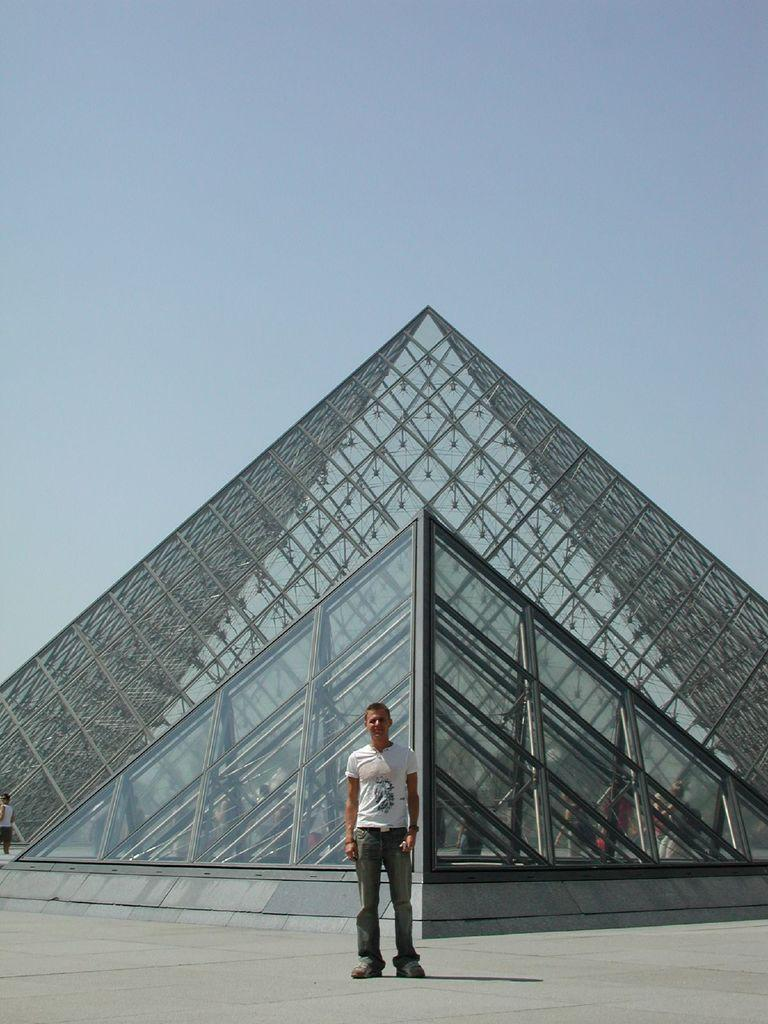How many people are in the image? There is a group of people in the image, but the exact number is not specified. What can be seen in the background of the image? There is a pyramid building in the background of the image. What type of creature is sitting on top of the pyramid in the image? There is no creature present on top of the pyramid in the image. What nation is the pyramid in the image associated with? The provided facts do not specify which nation the pyramid is associated with. 